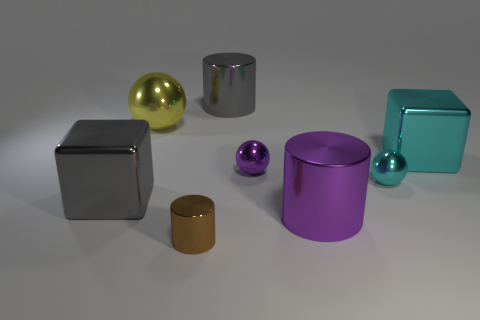Add 1 brown cylinders. How many objects exist? 9 Subtract all cylinders. How many objects are left? 5 Add 8 large brown shiny cubes. How many large brown shiny cubes exist? 8 Subtract 0 red cylinders. How many objects are left? 8 Subtract all purple metal things. Subtract all big gray objects. How many objects are left? 4 Add 5 purple spheres. How many purple spheres are left? 6 